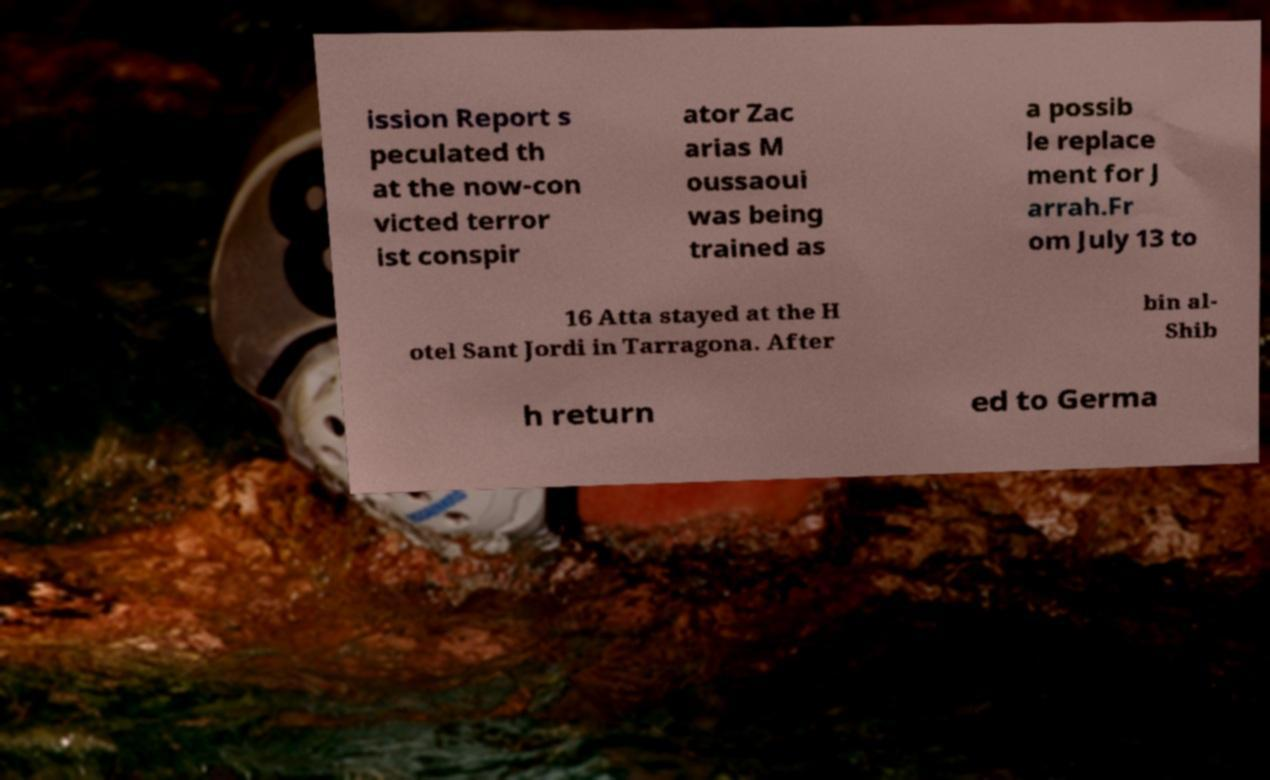Could you assist in decoding the text presented in this image and type it out clearly? ission Report s peculated th at the now-con victed terror ist conspir ator Zac arias M oussaoui was being trained as a possib le replace ment for J arrah.Fr om July 13 to 16 Atta stayed at the H otel Sant Jordi in Tarragona. After bin al- Shib h return ed to Germa 